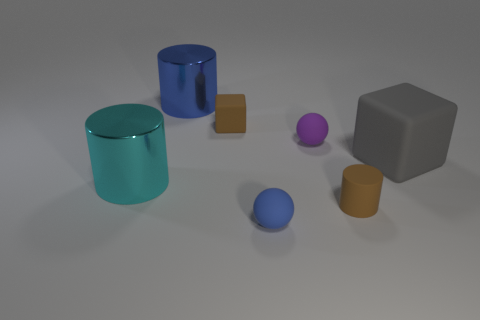What color is the object that is left of the large blue metallic object?
Make the answer very short. Cyan. Are there any other tiny blue objects that have the same shape as the tiny blue thing?
Your answer should be very brief. No. How many gray objects are tiny cylinders or rubber spheres?
Your answer should be compact. 0. Are there any purple matte objects that have the same size as the blue shiny thing?
Give a very brief answer. No. How many gray cylinders are there?
Ensure brevity in your answer.  0. How many small things are either cyan rubber cylinders or cubes?
Your answer should be compact. 1. There is a big block that is in front of the tiny sphere right of the blue object right of the big blue object; what color is it?
Provide a succinct answer. Gray. What number of other things are the same color as the small cylinder?
Provide a short and direct response. 1. How many rubber objects are either tiny cylinders or tiny brown balls?
Ensure brevity in your answer.  1. There is a large thing that is to the right of the blue cylinder; is its color the same as the cylinder behind the gray rubber thing?
Provide a short and direct response. No. 